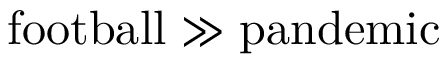Convert formula to latex. <formula><loc_0><loc_0><loc_500><loc_500>f o o t b a l l \gg p a n d e m i c</formula> 